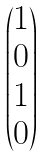<formula> <loc_0><loc_0><loc_500><loc_500>\begin{pmatrix} 1 \\ 0 \\ 1 \\ 0 \end{pmatrix}</formula> 